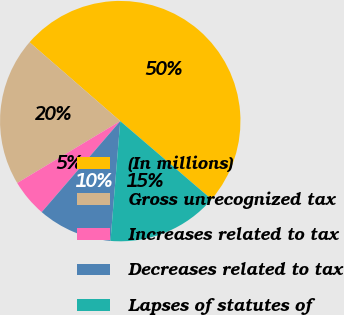Convert chart. <chart><loc_0><loc_0><loc_500><loc_500><pie_chart><fcel>(In millions)<fcel>Gross unrecognized tax<fcel>Increases related to tax<fcel>Decreases related to tax<fcel>Lapses of statutes of<nl><fcel>49.89%<fcel>20.0%<fcel>5.06%<fcel>10.04%<fcel>15.02%<nl></chart> 